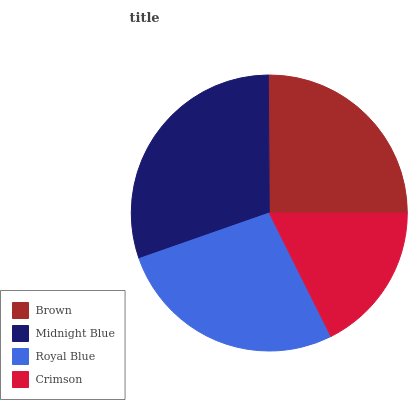Is Crimson the minimum?
Answer yes or no. Yes. Is Midnight Blue the maximum?
Answer yes or no. Yes. Is Royal Blue the minimum?
Answer yes or no. No. Is Royal Blue the maximum?
Answer yes or no. No. Is Midnight Blue greater than Royal Blue?
Answer yes or no. Yes. Is Royal Blue less than Midnight Blue?
Answer yes or no. Yes. Is Royal Blue greater than Midnight Blue?
Answer yes or no. No. Is Midnight Blue less than Royal Blue?
Answer yes or no. No. Is Royal Blue the high median?
Answer yes or no. Yes. Is Brown the low median?
Answer yes or no. Yes. Is Brown the high median?
Answer yes or no. No. Is Crimson the low median?
Answer yes or no. No. 